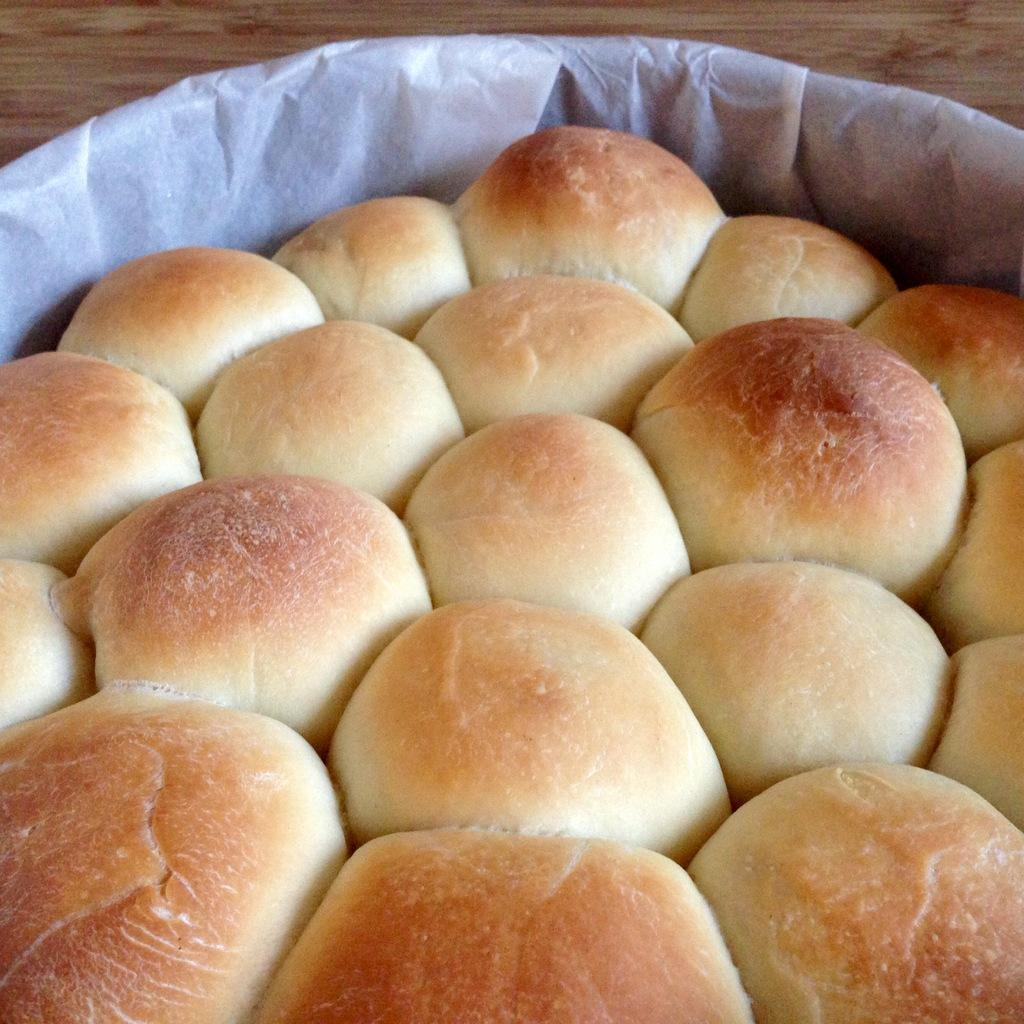What is the main object in the image? There is a container in the image. What is inside the container? The container holds buns. Where is the container placed? The container is on a wooden platform. What type of toothpaste is being used by the family in the image? There is no family or toothpaste present in the image; it only features a container holding buns on a wooden platform. 